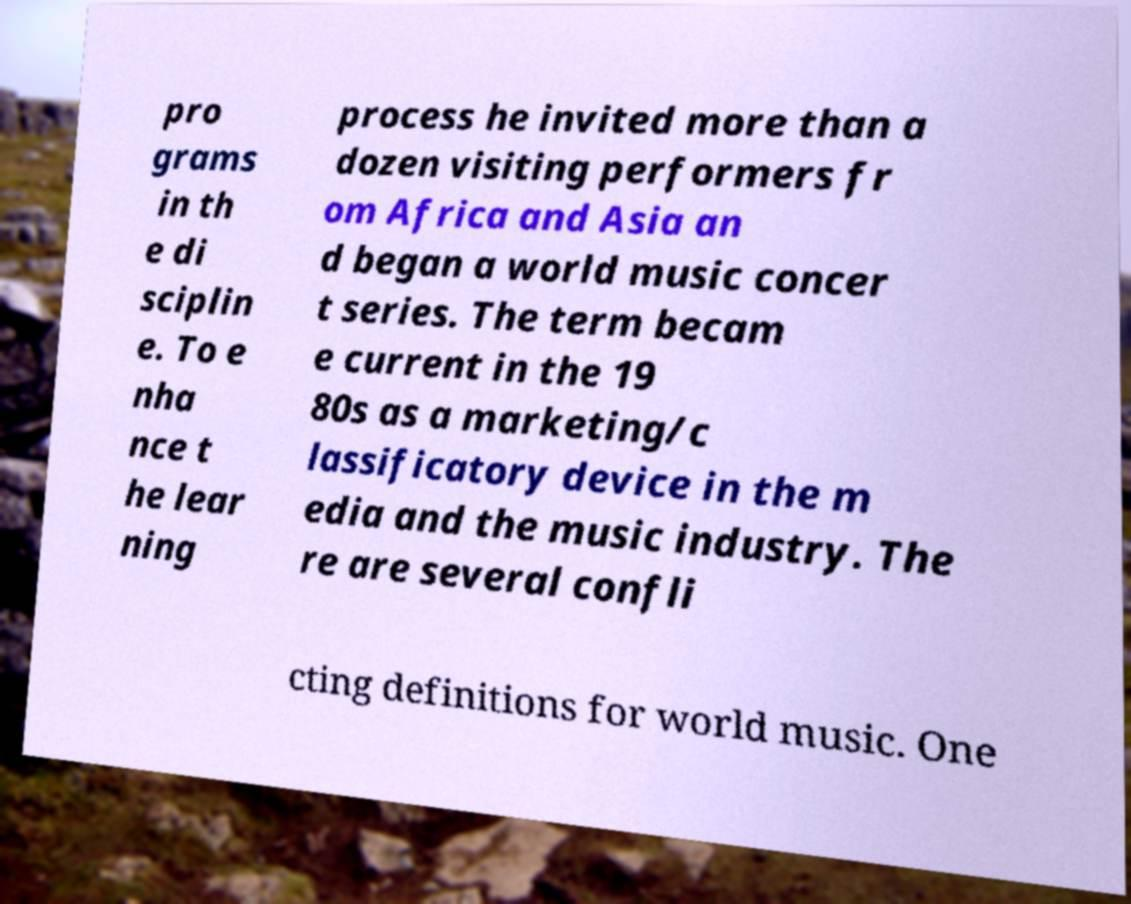There's text embedded in this image that I need extracted. Can you transcribe it verbatim? pro grams in th e di sciplin e. To e nha nce t he lear ning process he invited more than a dozen visiting performers fr om Africa and Asia an d began a world music concer t series. The term becam e current in the 19 80s as a marketing/c lassificatory device in the m edia and the music industry. The re are several confli cting definitions for world music. One 